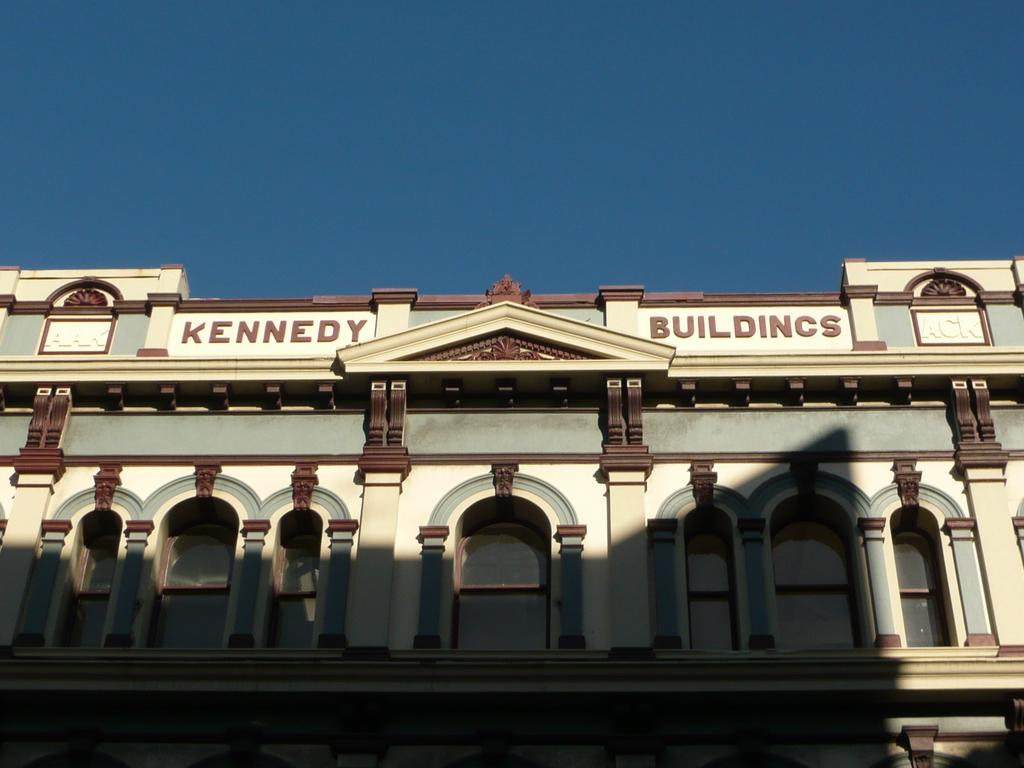What type of structure is present in the image? There is a building in the image. Can you describe any specific features of the building? The building has some text on it. What can be seen in the background of the image? The sky is visible in the image. What type of clam is being sold in the shop in the image? There is no shop or clam present in the image; it only features a building with text on it and the sky in the background. 